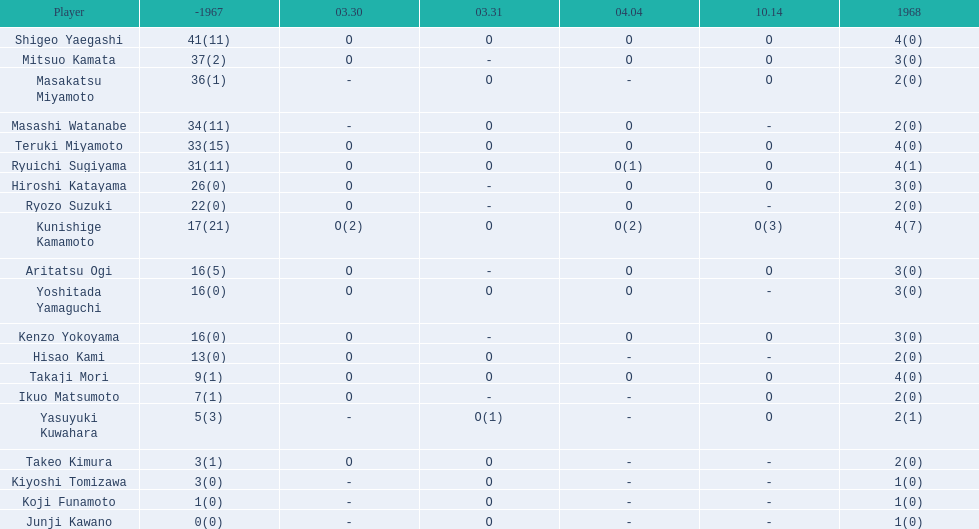Who were the players in the 1968 japanese football? Shigeo Yaegashi, Mitsuo Kamata, Masakatsu Miyamoto, Masashi Watanabe, Teruki Miyamoto, Ryuichi Sugiyama, Hiroshi Katayama, Ryozo Suzuki, Kunishige Kamamoto, Aritatsu Ogi, Yoshitada Yamaguchi, Kenzo Yokoyama, Hisao Kami, Takaji Mori, Ikuo Matsumoto, Yasuyuki Kuwahara, Takeo Kimura, Kiyoshi Tomizawa, Koji Funamoto, Junji Kawano. How many points total did takaji mori have? 13(1). How many points total did junju kawano? 1(0). Who had more points? Takaji Mori. 